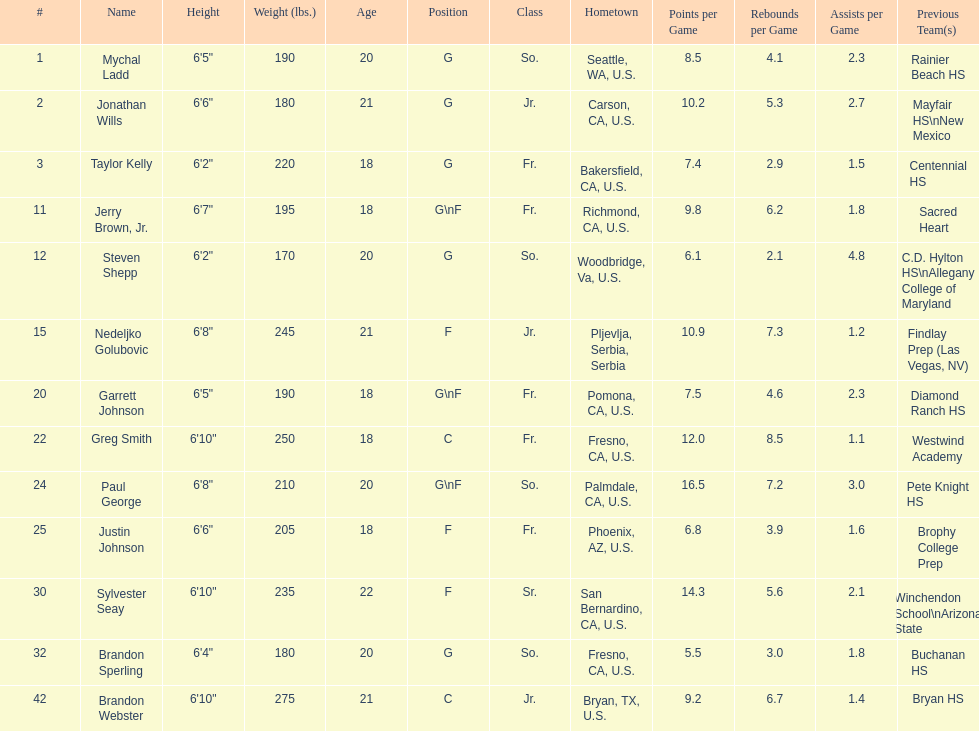What is the number of players who weight over 200 pounds? 7. 